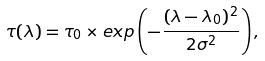Convert formula to latex. <formula><loc_0><loc_0><loc_500><loc_500>\tau ( \lambda ) = \tau _ { 0 } \times e x p \left ( - \frac { ( \lambda - \lambda _ { 0 } ) ^ { 2 } } { 2 \sigma ^ { 2 } } \right ) ,</formula> 